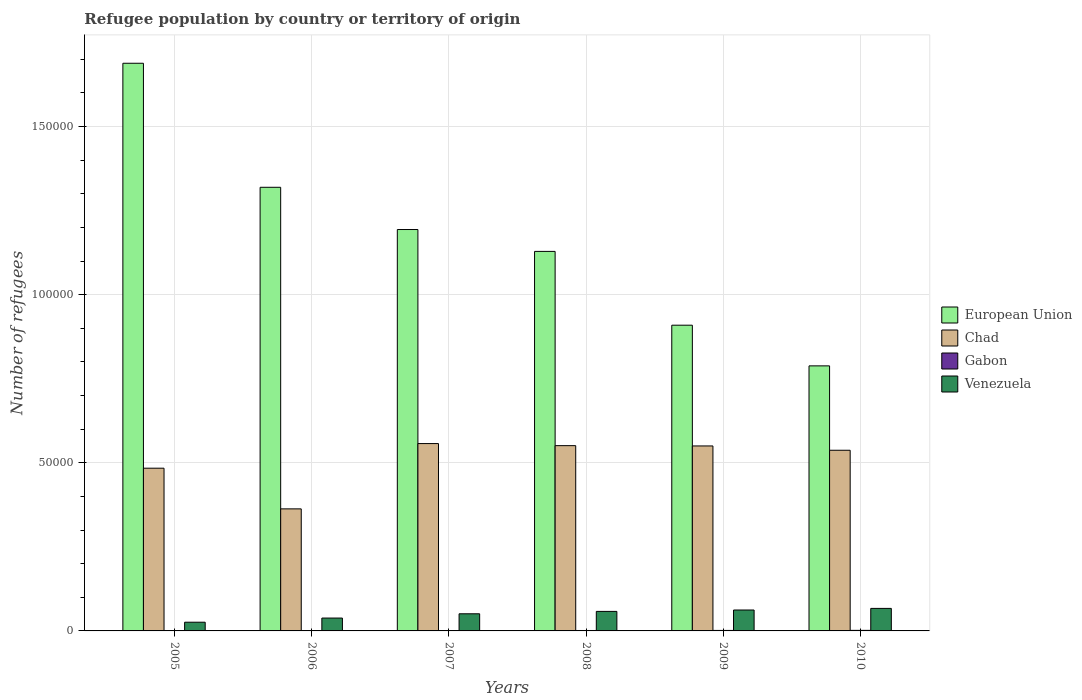How many groups of bars are there?
Your answer should be very brief. 6. How many bars are there on the 3rd tick from the left?
Your answer should be compact. 4. What is the number of refugees in Gabon in 2007?
Your answer should be very brief. 116. Across all years, what is the maximum number of refugees in Gabon?
Your answer should be very brief. 165. Across all years, what is the minimum number of refugees in Chad?
Ensure brevity in your answer.  3.63e+04. In which year was the number of refugees in European Union minimum?
Offer a very short reply. 2010. What is the total number of refugees in Venezuela in the graph?
Give a very brief answer. 3.02e+04. What is the difference between the number of refugees in Chad in 2009 and that in 2010?
Your answer should be very brief. 1281. What is the difference between the number of refugees in Venezuela in 2010 and the number of refugees in Gabon in 2009?
Your answer should be very brief. 6557. What is the average number of refugees in Gabon per year?
Your response must be concise. 121.67. In the year 2010, what is the difference between the number of refugees in European Union and number of refugees in Gabon?
Make the answer very short. 7.87e+04. In how many years, is the number of refugees in Venezuela greater than 100000?
Your answer should be compact. 0. What is the ratio of the number of refugees in Venezuela in 2005 to that in 2009?
Keep it short and to the point. 0.42. Is the number of refugees in European Union in 2005 less than that in 2009?
Ensure brevity in your answer.  No. What is the difference between the highest and the second highest number of refugees in Chad?
Offer a very short reply. 617. What is the difference between the highest and the lowest number of refugees in Venezuela?
Offer a very short reply. 4111. Is the sum of the number of refugees in Chad in 2006 and 2009 greater than the maximum number of refugees in European Union across all years?
Provide a succinct answer. No. Is it the case that in every year, the sum of the number of refugees in Venezuela and number of refugees in Gabon is greater than the sum of number of refugees in Chad and number of refugees in European Union?
Offer a terse response. Yes. What does the 4th bar from the left in 2007 represents?
Offer a very short reply. Venezuela. What does the 2nd bar from the right in 2005 represents?
Offer a terse response. Gabon. Is it the case that in every year, the sum of the number of refugees in Chad and number of refugees in Gabon is greater than the number of refugees in European Union?
Provide a short and direct response. No. How many bars are there?
Your answer should be compact. 24. Are all the bars in the graph horizontal?
Your answer should be compact. No. How many years are there in the graph?
Provide a short and direct response. 6. Does the graph contain any zero values?
Offer a very short reply. No. How many legend labels are there?
Ensure brevity in your answer.  4. How are the legend labels stacked?
Your response must be concise. Vertical. What is the title of the graph?
Offer a terse response. Refugee population by country or territory of origin. Does "Kosovo" appear as one of the legend labels in the graph?
Keep it short and to the point. No. What is the label or title of the X-axis?
Give a very brief answer. Years. What is the label or title of the Y-axis?
Your answer should be very brief. Number of refugees. What is the Number of refugees of European Union in 2005?
Offer a terse response. 1.69e+05. What is the Number of refugees in Chad in 2005?
Your response must be concise. 4.84e+04. What is the Number of refugees of Gabon in 2005?
Offer a very short reply. 81. What is the Number of refugees of Venezuela in 2005?
Your answer should be very brief. 2590. What is the Number of refugees of European Union in 2006?
Offer a very short reply. 1.32e+05. What is the Number of refugees of Chad in 2006?
Offer a terse response. 3.63e+04. What is the Number of refugees of Gabon in 2006?
Offer a very short reply. 95. What is the Number of refugees in Venezuela in 2006?
Give a very brief answer. 3829. What is the Number of refugees of European Union in 2007?
Give a very brief answer. 1.19e+05. What is the Number of refugees of Chad in 2007?
Make the answer very short. 5.57e+04. What is the Number of refugees in Gabon in 2007?
Your answer should be compact. 116. What is the Number of refugees in Venezuela in 2007?
Keep it short and to the point. 5094. What is the Number of refugees in European Union in 2008?
Ensure brevity in your answer.  1.13e+05. What is the Number of refugees in Chad in 2008?
Offer a terse response. 5.51e+04. What is the Number of refugees in Gabon in 2008?
Provide a short and direct response. 129. What is the Number of refugees of Venezuela in 2008?
Ensure brevity in your answer.  5807. What is the Number of refugees of European Union in 2009?
Your answer should be compact. 9.09e+04. What is the Number of refugees of Chad in 2009?
Offer a terse response. 5.50e+04. What is the Number of refugees of Gabon in 2009?
Offer a terse response. 144. What is the Number of refugees in Venezuela in 2009?
Your answer should be compact. 6221. What is the Number of refugees in European Union in 2010?
Your answer should be very brief. 7.88e+04. What is the Number of refugees of Chad in 2010?
Keep it short and to the point. 5.37e+04. What is the Number of refugees of Gabon in 2010?
Make the answer very short. 165. What is the Number of refugees of Venezuela in 2010?
Provide a short and direct response. 6701. Across all years, what is the maximum Number of refugees of European Union?
Ensure brevity in your answer.  1.69e+05. Across all years, what is the maximum Number of refugees in Chad?
Make the answer very short. 5.57e+04. Across all years, what is the maximum Number of refugees in Gabon?
Provide a short and direct response. 165. Across all years, what is the maximum Number of refugees of Venezuela?
Provide a succinct answer. 6701. Across all years, what is the minimum Number of refugees in European Union?
Ensure brevity in your answer.  7.88e+04. Across all years, what is the minimum Number of refugees of Chad?
Give a very brief answer. 3.63e+04. Across all years, what is the minimum Number of refugees of Venezuela?
Provide a short and direct response. 2590. What is the total Number of refugees of European Union in the graph?
Offer a very short reply. 7.03e+05. What is the total Number of refugees of Chad in the graph?
Offer a terse response. 3.04e+05. What is the total Number of refugees of Gabon in the graph?
Make the answer very short. 730. What is the total Number of refugees in Venezuela in the graph?
Offer a terse response. 3.02e+04. What is the difference between the Number of refugees in European Union in 2005 and that in 2006?
Give a very brief answer. 3.69e+04. What is the difference between the Number of refugees in Chad in 2005 and that in 2006?
Your response must be concise. 1.21e+04. What is the difference between the Number of refugees of Gabon in 2005 and that in 2006?
Keep it short and to the point. -14. What is the difference between the Number of refugees of Venezuela in 2005 and that in 2006?
Offer a terse response. -1239. What is the difference between the Number of refugees in European Union in 2005 and that in 2007?
Keep it short and to the point. 4.94e+04. What is the difference between the Number of refugees in Chad in 2005 and that in 2007?
Provide a succinct answer. -7322. What is the difference between the Number of refugees in Gabon in 2005 and that in 2007?
Offer a terse response. -35. What is the difference between the Number of refugees in Venezuela in 2005 and that in 2007?
Offer a very short reply. -2504. What is the difference between the Number of refugees of European Union in 2005 and that in 2008?
Give a very brief answer. 5.60e+04. What is the difference between the Number of refugees of Chad in 2005 and that in 2008?
Provide a succinct answer. -6705. What is the difference between the Number of refugees in Gabon in 2005 and that in 2008?
Offer a very short reply. -48. What is the difference between the Number of refugees of Venezuela in 2005 and that in 2008?
Give a very brief answer. -3217. What is the difference between the Number of refugees in European Union in 2005 and that in 2009?
Ensure brevity in your answer.  7.79e+04. What is the difference between the Number of refugees in Chad in 2005 and that in 2009?
Give a very brief answer. -6614. What is the difference between the Number of refugees in Gabon in 2005 and that in 2009?
Your answer should be very brief. -63. What is the difference between the Number of refugees of Venezuela in 2005 and that in 2009?
Provide a short and direct response. -3631. What is the difference between the Number of refugees of European Union in 2005 and that in 2010?
Ensure brevity in your answer.  9.00e+04. What is the difference between the Number of refugees in Chad in 2005 and that in 2010?
Keep it short and to the point. -5333. What is the difference between the Number of refugees of Gabon in 2005 and that in 2010?
Ensure brevity in your answer.  -84. What is the difference between the Number of refugees of Venezuela in 2005 and that in 2010?
Your response must be concise. -4111. What is the difference between the Number of refugees of European Union in 2006 and that in 2007?
Provide a short and direct response. 1.26e+04. What is the difference between the Number of refugees of Chad in 2006 and that in 2007?
Give a very brief answer. -1.94e+04. What is the difference between the Number of refugees in Gabon in 2006 and that in 2007?
Provide a succinct answer. -21. What is the difference between the Number of refugees in Venezuela in 2006 and that in 2007?
Your answer should be compact. -1265. What is the difference between the Number of refugees of European Union in 2006 and that in 2008?
Keep it short and to the point. 1.91e+04. What is the difference between the Number of refugees of Chad in 2006 and that in 2008?
Provide a short and direct response. -1.88e+04. What is the difference between the Number of refugees of Gabon in 2006 and that in 2008?
Give a very brief answer. -34. What is the difference between the Number of refugees of Venezuela in 2006 and that in 2008?
Provide a short and direct response. -1978. What is the difference between the Number of refugees of European Union in 2006 and that in 2009?
Your response must be concise. 4.10e+04. What is the difference between the Number of refugees of Chad in 2006 and that in 2009?
Offer a terse response. -1.87e+04. What is the difference between the Number of refugees of Gabon in 2006 and that in 2009?
Provide a short and direct response. -49. What is the difference between the Number of refugees in Venezuela in 2006 and that in 2009?
Your answer should be very brief. -2392. What is the difference between the Number of refugees of European Union in 2006 and that in 2010?
Keep it short and to the point. 5.31e+04. What is the difference between the Number of refugees in Chad in 2006 and that in 2010?
Your response must be concise. -1.74e+04. What is the difference between the Number of refugees in Gabon in 2006 and that in 2010?
Provide a succinct answer. -70. What is the difference between the Number of refugees of Venezuela in 2006 and that in 2010?
Your answer should be very brief. -2872. What is the difference between the Number of refugees in European Union in 2007 and that in 2008?
Your response must be concise. 6509. What is the difference between the Number of refugees of Chad in 2007 and that in 2008?
Your answer should be very brief. 617. What is the difference between the Number of refugees of Gabon in 2007 and that in 2008?
Your response must be concise. -13. What is the difference between the Number of refugees in Venezuela in 2007 and that in 2008?
Your answer should be compact. -713. What is the difference between the Number of refugees of European Union in 2007 and that in 2009?
Make the answer very short. 2.85e+04. What is the difference between the Number of refugees of Chad in 2007 and that in 2009?
Your answer should be very brief. 708. What is the difference between the Number of refugees in Gabon in 2007 and that in 2009?
Provide a short and direct response. -28. What is the difference between the Number of refugees in Venezuela in 2007 and that in 2009?
Ensure brevity in your answer.  -1127. What is the difference between the Number of refugees in European Union in 2007 and that in 2010?
Your response must be concise. 4.06e+04. What is the difference between the Number of refugees in Chad in 2007 and that in 2010?
Make the answer very short. 1989. What is the difference between the Number of refugees in Gabon in 2007 and that in 2010?
Provide a short and direct response. -49. What is the difference between the Number of refugees in Venezuela in 2007 and that in 2010?
Your answer should be compact. -1607. What is the difference between the Number of refugees in European Union in 2008 and that in 2009?
Provide a short and direct response. 2.19e+04. What is the difference between the Number of refugees of Chad in 2008 and that in 2009?
Give a very brief answer. 91. What is the difference between the Number of refugees of Venezuela in 2008 and that in 2009?
Keep it short and to the point. -414. What is the difference between the Number of refugees of European Union in 2008 and that in 2010?
Your answer should be compact. 3.40e+04. What is the difference between the Number of refugees in Chad in 2008 and that in 2010?
Ensure brevity in your answer.  1372. What is the difference between the Number of refugees of Gabon in 2008 and that in 2010?
Ensure brevity in your answer.  -36. What is the difference between the Number of refugees of Venezuela in 2008 and that in 2010?
Provide a succinct answer. -894. What is the difference between the Number of refugees of European Union in 2009 and that in 2010?
Offer a terse response. 1.21e+04. What is the difference between the Number of refugees of Chad in 2009 and that in 2010?
Your response must be concise. 1281. What is the difference between the Number of refugees of Gabon in 2009 and that in 2010?
Make the answer very short. -21. What is the difference between the Number of refugees in Venezuela in 2009 and that in 2010?
Keep it short and to the point. -480. What is the difference between the Number of refugees of European Union in 2005 and the Number of refugees of Chad in 2006?
Your response must be concise. 1.33e+05. What is the difference between the Number of refugees in European Union in 2005 and the Number of refugees in Gabon in 2006?
Offer a terse response. 1.69e+05. What is the difference between the Number of refugees of European Union in 2005 and the Number of refugees of Venezuela in 2006?
Provide a succinct answer. 1.65e+05. What is the difference between the Number of refugees in Chad in 2005 and the Number of refugees in Gabon in 2006?
Your answer should be very brief. 4.83e+04. What is the difference between the Number of refugees in Chad in 2005 and the Number of refugees in Venezuela in 2006?
Offer a very short reply. 4.46e+04. What is the difference between the Number of refugees of Gabon in 2005 and the Number of refugees of Venezuela in 2006?
Ensure brevity in your answer.  -3748. What is the difference between the Number of refugees in European Union in 2005 and the Number of refugees in Chad in 2007?
Make the answer very short. 1.13e+05. What is the difference between the Number of refugees of European Union in 2005 and the Number of refugees of Gabon in 2007?
Offer a very short reply. 1.69e+05. What is the difference between the Number of refugees in European Union in 2005 and the Number of refugees in Venezuela in 2007?
Provide a succinct answer. 1.64e+05. What is the difference between the Number of refugees in Chad in 2005 and the Number of refugees in Gabon in 2007?
Provide a succinct answer. 4.83e+04. What is the difference between the Number of refugees in Chad in 2005 and the Number of refugees in Venezuela in 2007?
Offer a terse response. 4.33e+04. What is the difference between the Number of refugees in Gabon in 2005 and the Number of refugees in Venezuela in 2007?
Provide a succinct answer. -5013. What is the difference between the Number of refugees in European Union in 2005 and the Number of refugees in Chad in 2008?
Offer a very short reply. 1.14e+05. What is the difference between the Number of refugees in European Union in 2005 and the Number of refugees in Gabon in 2008?
Provide a succinct answer. 1.69e+05. What is the difference between the Number of refugees in European Union in 2005 and the Number of refugees in Venezuela in 2008?
Make the answer very short. 1.63e+05. What is the difference between the Number of refugees in Chad in 2005 and the Number of refugees in Gabon in 2008?
Your response must be concise. 4.83e+04. What is the difference between the Number of refugees of Chad in 2005 and the Number of refugees of Venezuela in 2008?
Ensure brevity in your answer.  4.26e+04. What is the difference between the Number of refugees in Gabon in 2005 and the Number of refugees in Venezuela in 2008?
Ensure brevity in your answer.  -5726. What is the difference between the Number of refugees in European Union in 2005 and the Number of refugees in Chad in 2009?
Provide a succinct answer. 1.14e+05. What is the difference between the Number of refugees in European Union in 2005 and the Number of refugees in Gabon in 2009?
Offer a very short reply. 1.69e+05. What is the difference between the Number of refugees in European Union in 2005 and the Number of refugees in Venezuela in 2009?
Provide a succinct answer. 1.63e+05. What is the difference between the Number of refugees in Chad in 2005 and the Number of refugees in Gabon in 2009?
Keep it short and to the point. 4.83e+04. What is the difference between the Number of refugees of Chad in 2005 and the Number of refugees of Venezuela in 2009?
Offer a terse response. 4.22e+04. What is the difference between the Number of refugees of Gabon in 2005 and the Number of refugees of Venezuela in 2009?
Give a very brief answer. -6140. What is the difference between the Number of refugees of European Union in 2005 and the Number of refugees of Chad in 2010?
Make the answer very short. 1.15e+05. What is the difference between the Number of refugees in European Union in 2005 and the Number of refugees in Gabon in 2010?
Ensure brevity in your answer.  1.69e+05. What is the difference between the Number of refugees of European Union in 2005 and the Number of refugees of Venezuela in 2010?
Make the answer very short. 1.62e+05. What is the difference between the Number of refugees in Chad in 2005 and the Number of refugees in Gabon in 2010?
Offer a terse response. 4.82e+04. What is the difference between the Number of refugees in Chad in 2005 and the Number of refugees in Venezuela in 2010?
Provide a short and direct response. 4.17e+04. What is the difference between the Number of refugees of Gabon in 2005 and the Number of refugees of Venezuela in 2010?
Make the answer very short. -6620. What is the difference between the Number of refugees of European Union in 2006 and the Number of refugees of Chad in 2007?
Ensure brevity in your answer.  7.62e+04. What is the difference between the Number of refugees of European Union in 2006 and the Number of refugees of Gabon in 2007?
Your answer should be compact. 1.32e+05. What is the difference between the Number of refugees in European Union in 2006 and the Number of refugees in Venezuela in 2007?
Offer a terse response. 1.27e+05. What is the difference between the Number of refugees in Chad in 2006 and the Number of refugees in Gabon in 2007?
Offer a terse response. 3.62e+04. What is the difference between the Number of refugees in Chad in 2006 and the Number of refugees in Venezuela in 2007?
Provide a succinct answer. 3.12e+04. What is the difference between the Number of refugees of Gabon in 2006 and the Number of refugees of Venezuela in 2007?
Provide a succinct answer. -4999. What is the difference between the Number of refugees of European Union in 2006 and the Number of refugees of Chad in 2008?
Ensure brevity in your answer.  7.68e+04. What is the difference between the Number of refugees of European Union in 2006 and the Number of refugees of Gabon in 2008?
Your answer should be very brief. 1.32e+05. What is the difference between the Number of refugees in European Union in 2006 and the Number of refugees in Venezuela in 2008?
Provide a short and direct response. 1.26e+05. What is the difference between the Number of refugees of Chad in 2006 and the Number of refugees of Gabon in 2008?
Offer a terse response. 3.62e+04. What is the difference between the Number of refugees of Chad in 2006 and the Number of refugees of Venezuela in 2008?
Make the answer very short. 3.05e+04. What is the difference between the Number of refugees in Gabon in 2006 and the Number of refugees in Venezuela in 2008?
Offer a very short reply. -5712. What is the difference between the Number of refugees of European Union in 2006 and the Number of refugees of Chad in 2009?
Provide a succinct answer. 7.69e+04. What is the difference between the Number of refugees of European Union in 2006 and the Number of refugees of Gabon in 2009?
Keep it short and to the point. 1.32e+05. What is the difference between the Number of refugees of European Union in 2006 and the Number of refugees of Venezuela in 2009?
Your answer should be compact. 1.26e+05. What is the difference between the Number of refugees in Chad in 2006 and the Number of refugees in Gabon in 2009?
Your response must be concise. 3.62e+04. What is the difference between the Number of refugees in Chad in 2006 and the Number of refugees in Venezuela in 2009?
Offer a very short reply. 3.01e+04. What is the difference between the Number of refugees in Gabon in 2006 and the Number of refugees in Venezuela in 2009?
Make the answer very short. -6126. What is the difference between the Number of refugees of European Union in 2006 and the Number of refugees of Chad in 2010?
Your response must be concise. 7.82e+04. What is the difference between the Number of refugees of European Union in 2006 and the Number of refugees of Gabon in 2010?
Your answer should be compact. 1.32e+05. What is the difference between the Number of refugees in European Union in 2006 and the Number of refugees in Venezuela in 2010?
Make the answer very short. 1.25e+05. What is the difference between the Number of refugees of Chad in 2006 and the Number of refugees of Gabon in 2010?
Your answer should be compact. 3.61e+04. What is the difference between the Number of refugees of Chad in 2006 and the Number of refugees of Venezuela in 2010?
Provide a succinct answer. 2.96e+04. What is the difference between the Number of refugees in Gabon in 2006 and the Number of refugees in Venezuela in 2010?
Your answer should be compact. -6606. What is the difference between the Number of refugees in European Union in 2007 and the Number of refugees in Chad in 2008?
Your response must be concise. 6.43e+04. What is the difference between the Number of refugees of European Union in 2007 and the Number of refugees of Gabon in 2008?
Give a very brief answer. 1.19e+05. What is the difference between the Number of refugees of European Union in 2007 and the Number of refugees of Venezuela in 2008?
Provide a short and direct response. 1.14e+05. What is the difference between the Number of refugees of Chad in 2007 and the Number of refugees of Gabon in 2008?
Your answer should be compact. 5.56e+04. What is the difference between the Number of refugees of Chad in 2007 and the Number of refugees of Venezuela in 2008?
Keep it short and to the point. 4.99e+04. What is the difference between the Number of refugees of Gabon in 2007 and the Number of refugees of Venezuela in 2008?
Make the answer very short. -5691. What is the difference between the Number of refugees of European Union in 2007 and the Number of refugees of Chad in 2009?
Keep it short and to the point. 6.44e+04. What is the difference between the Number of refugees of European Union in 2007 and the Number of refugees of Gabon in 2009?
Keep it short and to the point. 1.19e+05. What is the difference between the Number of refugees in European Union in 2007 and the Number of refugees in Venezuela in 2009?
Ensure brevity in your answer.  1.13e+05. What is the difference between the Number of refugees of Chad in 2007 and the Number of refugees of Gabon in 2009?
Keep it short and to the point. 5.56e+04. What is the difference between the Number of refugees of Chad in 2007 and the Number of refugees of Venezuela in 2009?
Make the answer very short. 4.95e+04. What is the difference between the Number of refugees in Gabon in 2007 and the Number of refugees in Venezuela in 2009?
Your answer should be compact. -6105. What is the difference between the Number of refugees in European Union in 2007 and the Number of refugees in Chad in 2010?
Provide a short and direct response. 6.57e+04. What is the difference between the Number of refugees of European Union in 2007 and the Number of refugees of Gabon in 2010?
Your response must be concise. 1.19e+05. What is the difference between the Number of refugees in European Union in 2007 and the Number of refugees in Venezuela in 2010?
Keep it short and to the point. 1.13e+05. What is the difference between the Number of refugees of Chad in 2007 and the Number of refugees of Gabon in 2010?
Offer a very short reply. 5.56e+04. What is the difference between the Number of refugees in Chad in 2007 and the Number of refugees in Venezuela in 2010?
Ensure brevity in your answer.  4.90e+04. What is the difference between the Number of refugees in Gabon in 2007 and the Number of refugees in Venezuela in 2010?
Your response must be concise. -6585. What is the difference between the Number of refugees in European Union in 2008 and the Number of refugees in Chad in 2009?
Your answer should be compact. 5.79e+04. What is the difference between the Number of refugees in European Union in 2008 and the Number of refugees in Gabon in 2009?
Keep it short and to the point. 1.13e+05. What is the difference between the Number of refugees of European Union in 2008 and the Number of refugees of Venezuela in 2009?
Give a very brief answer. 1.07e+05. What is the difference between the Number of refugees in Chad in 2008 and the Number of refugees in Gabon in 2009?
Your answer should be very brief. 5.50e+04. What is the difference between the Number of refugees of Chad in 2008 and the Number of refugees of Venezuela in 2009?
Offer a terse response. 4.89e+04. What is the difference between the Number of refugees of Gabon in 2008 and the Number of refugees of Venezuela in 2009?
Keep it short and to the point. -6092. What is the difference between the Number of refugees of European Union in 2008 and the Number of refugees of Chad in 2010?
Offer a very short reply. 5.91e+04. What is the difference between the Number of refugees of European Union in 2008 and the Number of refugees of Gabon in 2010?
Ensure brevity in your answer.  1.13e+05. What is the difference between the Number of refugees in European Union in 2008 and the Number of refugees in Venezuela in 2010?
Offer a very short reply. 1.06e+05. What is the difference between the Number of refugees in Chad in 2008 and the Number of refugees in Gabon in 2010?
Provide a short and direct response. 5.49e+04. What is the difference between the Number of refugees of Chad in 2008 and the Number of refugees of Venezuela in 2010?
Provide a short and direct response. 4.84e+04. What is the difference between the Number of refugees of Gabon in 2008 and the Number of refugees of Venezuela in 2010?
Provide a succinct answer. -6572. What is the difference between the Number of refugees of European Union in 2009 and the Number of refugees of Chad in 2010?
Provide a succinct answer. 3.72e+04. What is the difference between the Number of refugees of European Union in 2009 and the Number of refugees of Gabon in 2010?
Your answer should be compact. 9.08e+04. What is the difference between the Number of refugees in European Union in 2009 and the Number of refugees in Venezuela in 2010?
Make the answer very short. 8.42e+04. What is the difference between the Number of refugees of Chad in 2009 and the Number of refugees of Gabon in 2010?
Make the answer very short. 5.48e+04. What is the difference between the Number of refugees of Chad in 2009 and the Number of refugees of Venezuela in 2010?
Give a very brief answer. 4.83e+04. What is the difference between the Number of refugees of Gabon in 2009 and the Number of refugees of Venezuela in 2010?
Ensure brevity in your answer.  -6557. What is the average Number of refugees in European Union per year?
Offer a terse response. 1.17e+05. What is the average Number of refugees of Chad per year?
Provide a succinct answer. 5.07e+04. What is the average Number of refugees in Gabon per year?
Your answer should be compact. 121.67. What is the average Number of refugees of Venezuela per year?
Ensure brevity in your answer.  5040.33. In the year 2005, what is the difference between the Number of refugees in European Union and Number of refugees in Chad?
Provide a short and direct response. 1.20e+05. In the year 2005, what is the difference between the Number of refugees in European Union and Number of refugees in Gabon?
Your answer should be very brief. 1.69e+05. In the year 2005, what is the difference between the Number of refugees in European Union and Number of refugees in Venezuela?
Offer a terse response. 1.66e+05. In the year 2005, what is the difference between the Number of refugees in Chad and Number of refugees in Gabon?
Your answer should be compact. 4.83e+04. In the year 2005, what is the difference between the Number of refugees in Chad and Number of refugees in Venezuela?
Give a very brief answer. 4.58e+04. In the year 2005, what is the difference between the Number of refugees of Gabon and Number of refugees of Venezuela?
Your answer should be very brief. -2509. In the year 2006, what is the difference between the Number of refugees of European Union and Number of refugees of Chad?
Keep it short and to the point. 9.56e+04. In the year 2006, what is the difference between the Number of refugees of European Union and Number of refugees of Gabon?
Your answer should be very brief. 1.32e+05. In the year 2006, what is the difference between the Number of refugees in European Union and Number of refugees in Venezuela?
Keep it short and to the point. 1.28e+05. In the year 2006, what is the difference between the Number of refugees of Chad and Number of refugees of Gabon?
Ensure brevity in your answer.  3.62e+04. In the year 2006, what is the difference between the Number of refugees in Chad and Number of refugees in Venezuela?
Offer a terse response. 3.25e+04. In the year 2006, what is the difference between the Number of refugees in Gabon and Number of refugees in Venezuela?
Your answer should be very brief. -3734. In the year 2007, what is the difference between the Number of refugees in European Union and Number of refugees in Chad?
Give a very brief answer. 6.37e+04. In the year 2007, what is the difference between the Number of refugees of European Union and Number of refugees of Gabon?
Your answer should be compact. 1.19e+05. In the year 2007, what is the difference between the Number of refugees in European Union and Number of refugees in Venezuela?
Offer a very short reply. 1.14e+05. In the year 2007, what is the difference between the Number of refugees in Chad and Number of refugees in Gabon?
Your response must be concise. 5.56e+04. In the year 2007, what is the difference between the Number of refugees of Chad and Number of refugees of Venezuela?
Keep it short and to the point. 5.06e+04. In the year 2007, what is the difference between the Number of refugees of Gabon and Number of refugees of Venezuela?
Ensure brevity in your answer.  -4978. In the year 2008, what is the difference between the Number of refugees in European Union and Number of refugees in Chad?
Keep it short and to the point. 5.78e+04. In the year 2008, what is the difference between the Number of refugees of European Union and Number of refugees of Gabon?
Offer a terse response. 1.13e+05. In the year 2008, what is the difference between the Number of refugees of European Union and Number of refugees of Venezuela?
Make the answer very short. 1.07e+05. In the year 2008, what is the difference between the Number of refugees in Chad and Number of refugees in Gabon?
Ensure brevity in your answer.  5.50e+04. In the year 2008, what is the difference between the Number of refugees of Chad and Number of refugees of Venezuela?
Give a very brief answer. 4.93e+04. In the year 2008, what is the difference between the Number of refugees in Gabon and Number of refugees in Venezuela?
Make the answer very short. -5678. In the year 2009, what is the difference between the Number of refugees of European Union and Number of refugees of Chad?
Keep it short and to the point. 3.59e+04. In the year 2009, what is the difference between the Number of refugees of European Union and Number of refugees of Gabon?
Your answer should be compact. 9.08e+04. In the year 2009, what is the difference between the Number of refugees of European Union and Number of refugees of Venezuela?
Provide a short and direct response. 8.47e+04. In the year 2009, what is the difference between the Number of refugees of Chad and Number of refugees of Gabon?
Make the answer very short. 5.49e+04. In the year 2009, what is the difference between the Number of refugees in Chad and Number of refugees in Venezuela?
Make the answer very short. 4.88e+04. In the year 2009, what is the difference between the Number of refugees in Gabon and Number of refugees in Venezuela?
Make the answer very short. -6077. In the year 2010, what is the difference between the Number of refugees of European Union and Number of refugees of Chad?
Provide a short and direct response. 2.51e+04. In the year 2010, what is the difference between the Number of refugees of European Union and Number of refugees of Gabon?
Give a very brief answer. 7.87e+04. In the year 2010, what is the difference between the Number of refugees in European Union and Number of refugees in Venezuela?
Provide a succinct answer. 7.21e+04. In the year 2010, what is the difference between the Number of refugees of Chad and Number of refugees of Gabon?
Ensure brevity in your answer.  5.36e+04. In the year 2010, what is the difference between the Number of refugees in Chad and Number of refugees in Venezuela?
Ensure brevity in your answer.  4.70e+04. In the year 2010, what is the difference between the Number of refugees in Gabon and Number of refugees in Venezuela?
Give a very brief answer. -6536. What is the ratio of the Number of refugees in European Union in 2005 to that in 2006?
Make the answer very short. 1.28. What is the ratio of the Number of refugees in Gabon in 2005 to that in 2006?
Your answer should be very brief. 0.85. What is the ratio of the Number of refugees of Venezuela in 2005 to that in 2006?
Provide a short and direct response. 0.68. What is the ratio of the Number of refugees in European Union in 2005 to that in 2007?
Offer a terse response. 1.41. What is the ratio of the Number of refugees in Chad in 2005 to that in 2007?
Give a very brief answer. 0.87. What is the ratio of the Number of refugees in Gabon in 2005 to that in 2007?
Ensure brevity in your answer.  0.7. What is the ratio of the Number of refugees in Venezuela in 2005 to that in 2007?
Provide a short and direct response. 0.51. What is the ratio of the Number of refugees of European Union in 2005 to that in 2008?
Your response must be concise. 1.5. What is the ratio of the Number of refugees of Chad in 2005 to that in 2008?
Keep it short and to the point. 0.88. What is the ratio of the Number of refugees in Gabon in 2005 to that in 2008?
Offer a very short reply. 0.63. What is the ratio of the Number of refugees in Venezuela in 2005 to that in 2008?
Offer a very short reply. 0.45. What is the ratio of the Number of refugees of European Union in 2005 to that in 2009?
Provide a succinct answer. 1.86. What is the ratio of the Number of refugees of Chad in 2005 to that in 2009?
Make the answer very short. 0.88. What is the ratio of the Number of refugees of Gabon in 2005 to that in 2009?
Provide a short and direct response. 0.56. What is the ratio of the Number of refugees of Venezuela in 2005 to that in 2009?
Provide a succinct answer. 0.42. What is the ratio of the Number of refugees of European Union in 2005 to that in 2010?
Provide a short and direct response. 2.14. What is the ratio of the Number of refugees of Chad in 2005 to that in 2010?
Ensure brevity in your answer.  0.9. What is the ratio of the Number of refugees of Gabon in 2005 to that in 2010?
Provide a succinct answer. 0.49. What is the ratio of the Number of refugees of Venezuela in 2005 to that in 2010?
Keep it short and to the point. 0.39. What is the ratio of the Number of refugees in European Union in 2006 to that in 2007?
Your response must be concise. 1.11. What is the ratio of the Number of refugees in Chad in 2006 to that in 2007?
Ensure brevity in your answer.  0.65. What is the ratio of the Number of refugees in Gabon in 2006 to that in 2007?
Provide a short and direct response. 0.82. What is the ratio of the Number of refugees of Venezuela in 2006 to that in 2007?
Your answer should be very brief. 0.75. What is the ratio of the Number of refugees in European Union in 2006 to that in 2008?
Keep it short and to the point. 1.17. What is the ratio of the Number of refugees in Chad in 2006 to that in 2008?
Ensure brevity in your answer.  0.66. What is the ratio of the Number of refugees in Gabon in 2006 to that in 2008?
Offer a terse response. 0.74. What is the ratio of the Number of refugees in Venezuela in 2006 to that in 2008?
Ensure brevity in your answer.  0.66. What is the ratio of the Number of refugees of European Union in 2006 to that in 2009?
Offer a terse response. 1.45. What is the ratio of the Number of refugees in Chad in 2006 to that in 2009?
Offer a very short reply. 0.66. What is the ratio of the Number of refugees in Gabon in 2006 to that in 2009?
Your response must be concise. 0.66. What is the ratio of the Number of refugees of Venezuela in 2006 to that in 2009?
Offer a terse response. 0.62. What is the ratio of the Number of refugees in European Union in 2006 to that in 2010?
Keep it short and to the point. 1.67. What is the ratio of the Number of refugees in Chad in 2006 to that in 2010?
Give a very brief answer. 0.68. What is the ratio of the Number of refugees of Gabon in 2006 to that in 2010?
Make the answer very short. 0.58. What is the ratio of the Number of refugees in European Union in 2007 to that in 2008?
Provide a succinct answer. 1.06. What is the ratio of the Number of refugees in Chad in 2007 to that in 2008?
Offer a very short reply. 1.01. What is the ratio of the Number of refugees in Gabon in 2007 to that in 2008?
Provide a succinct answer. 0.9. What is the ratio of the Number of refugees in Venezuela in 2007 to that in 2008?
Make the answer very short. 0.88. What is the ratio of the Number of refugees of European Union in 2007 to that in 2009?
Make the answer very short. 1.31. What is the ratio of the Number of refugees in Chad in 2007 to that in 2009?
Ensure brevity in your answer.  1.01. What is the ratio of the Number of refugees in Gabon in 2007 to that in 2009?
Your answer should be very brief. 0.81. What is the ratio of the Number of refugees of Venezuela in 2007 to that in 2009?
Provide a short and direct response. 0.82. What is the ratio of the Number of refugees in European Union in 2007 to that in 2010?
Offer a very short reply. 1.51. What is the ratio of the Number of refugees of Gabon in 2007 to that in 2010?
Make the answer very short. 0.7. What is the ratio of the Number of refugees of Venezuela in 2007 to that in 2010?
Your answer should be compact. 0.76. What is the ratio of the Number of refugees of European Union in 2008 to that in 2009?
Make the answer very short. 1.24. What is the ratio of the Number of refugees in Gabon in 2008 to that in 2009?
Your answer should be very brief. 0.9. What is the ratio of the Number of refugees of Venezuela in 2008 to that in 2009?
Keep it short and to the point. 0.93. What is the ratio of the Number of refugees of European Union in 2008 to that in 2010?
Offer a terse response. 1.43. What is the ratio of the Number of refugees in Chad in 2008 to that in 2010?
Provide a succinct answer. 1.03. What is the ratio of the Number of refugees of Gabon in 2008 to that in 2010?
Provide a succinct answer. 0.78. What is the ratio of the Number of refugees of Venezuela in 2008 to that in 2010?
Your answer should be compact. 0.87. What is the ratio of the Number of refugees of European Union in 2009 to that in 2010?
Your answer should be compact. 1.15. What is the ratio of the Number of refugees in Chad in 2009 to that in 2010?
Offer a terse response. 1.02. What is the ratio of the Number of refugees of Gabon in 2009 to that in 2010?
Offer a very short reply. 0.87. What is the ratio of the Number of refugees of Venezuela in 2009 to that in 2010?
Keep it short and to the point. 0.93. What is the difference between the highest and the second highest Number of refugees of European Union?
Offer a very short reply. 3.69e+04. What is the difference between the highest and the second highest Number of refugees of Chad?
Provide a short and direct response. 617. What is the difference between the highest and the second highest Number of refugees of Gabon?
Offer a terse response. 21. What is the difference between the highest and the second highest Number of refugees in Venezuela?
Offer a terse response. 480. What is the difference between the highest and the lowest Number of refugees in European Union?
Your answer should be compact. 9.00e+04. What is the difference between the highest and the lowest Number of refugees of Chad?
Offer a very short reply. 1.94e+04. What is the difference between the highest and the lowest Number of refugees in Venezuela?
Your response must be concise. 4111. 